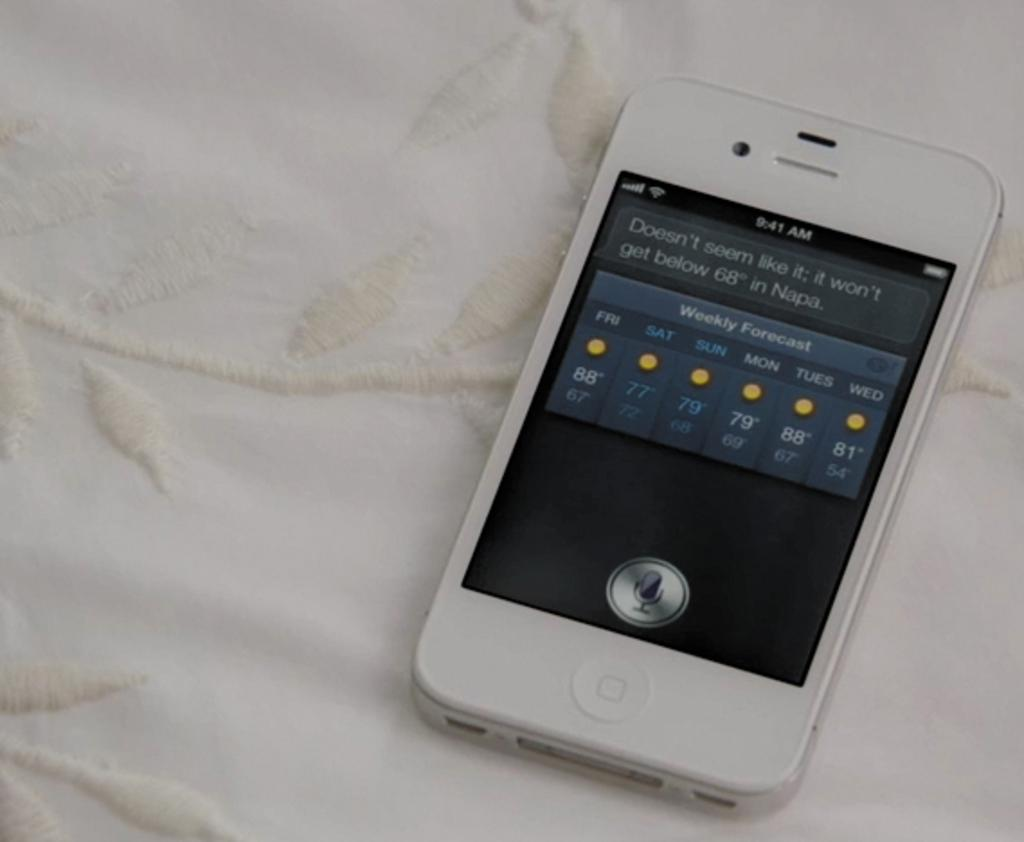What is the main subject of the image? The main subject of the image is a mobile. Where is the mobile located in the image? The mobile is in the center of the image. What is the mobile placed on? The mobile is placed on a white cloth. How many kittens are playing with the flag attached to the mobile in the image? There are no kittens or flags present in the image. What type of hook is used to hang the mobile in the image? There is no hook visible in the image, as the mobile appears to be resting on a white cloth. 